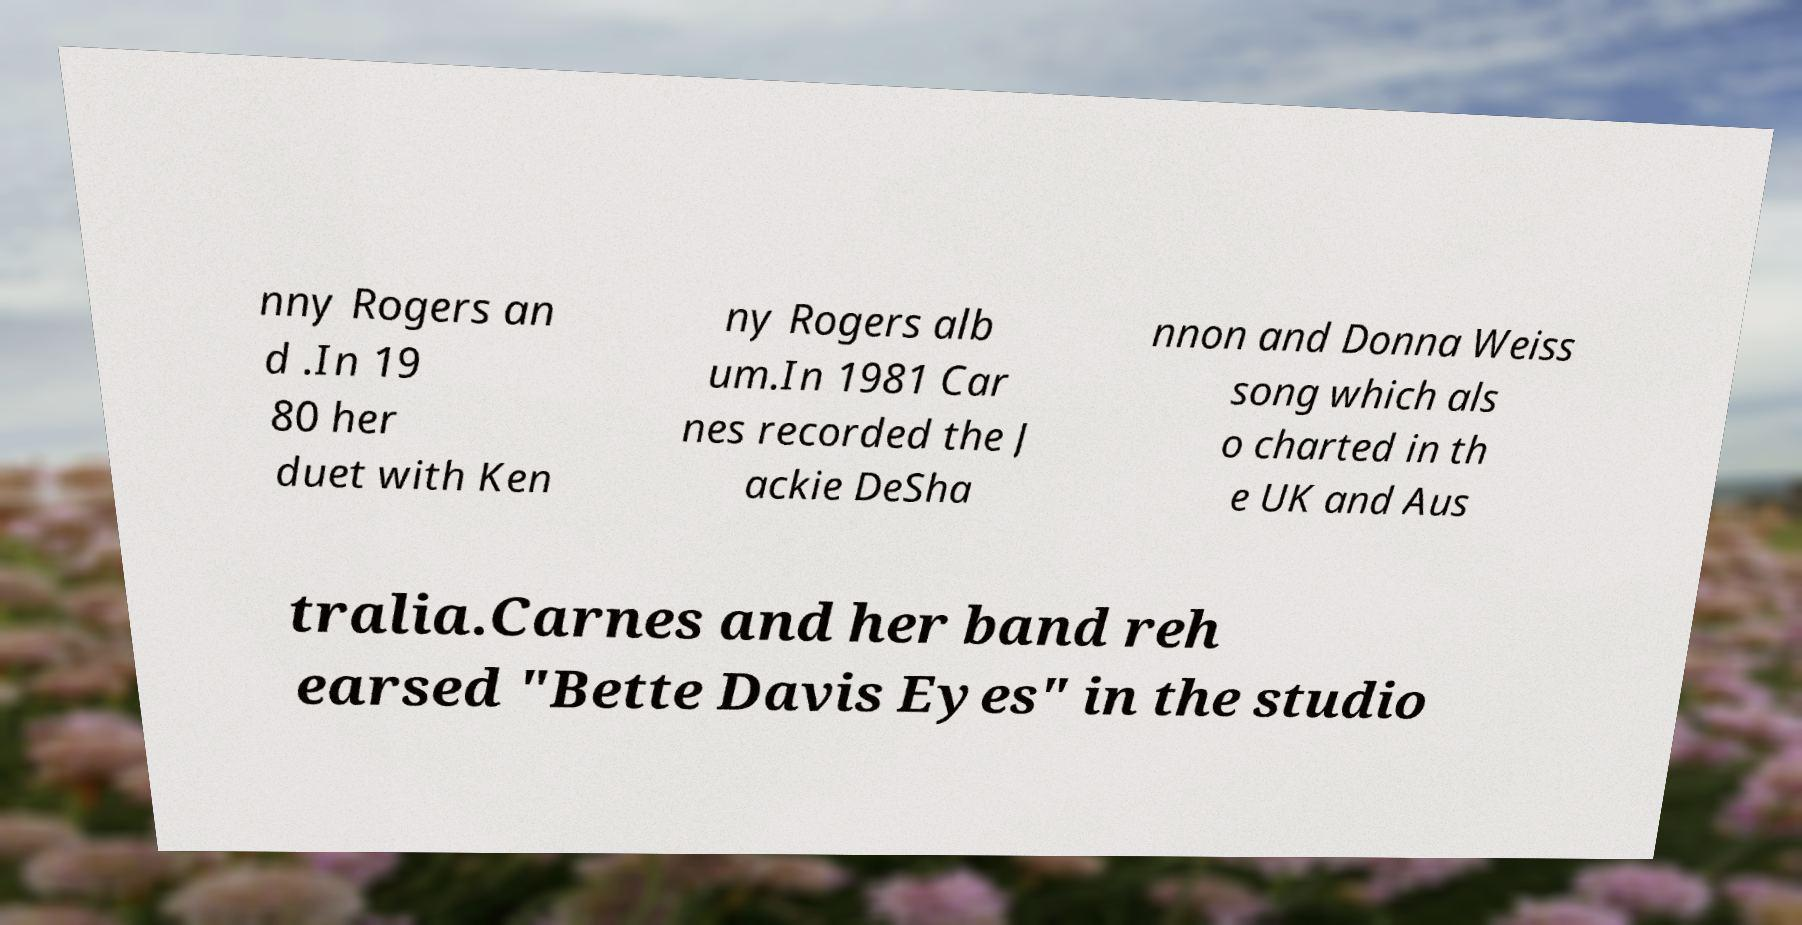Can you accurately transcribe the text from the provided image for me? nny Rogers an d .In 19 80 her duet with Ken ny Rogers alb um.In 1981 Car nes recorded the J ackie DeSha nnon and Donna Weiss song which als o charted in th e UK and Aus tralia.Carnes and her band reh earsed "Bette Davis Eyes" in the studio 